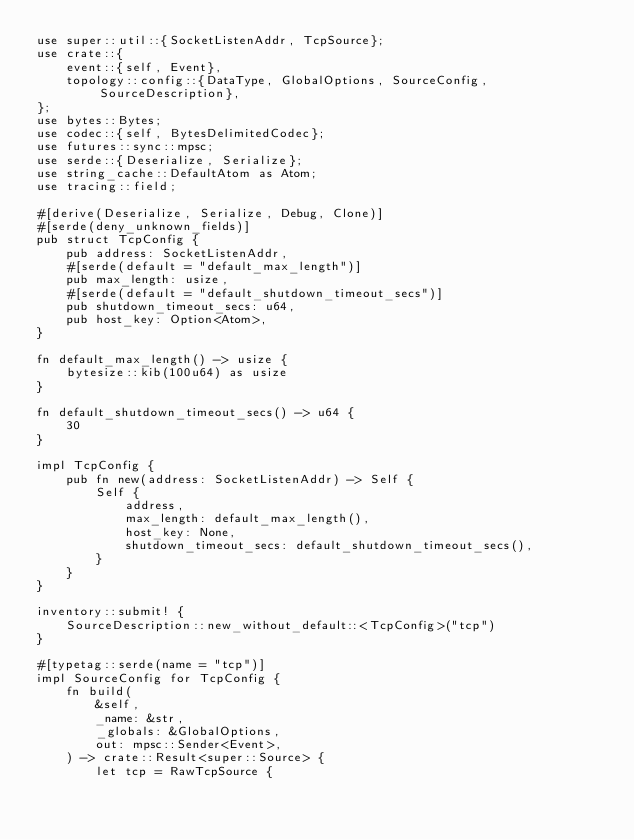Convert code to text. <code><loc_0><loc_0><loc_500><loc_500><_Rust_>use super::util::{SocketListenAddr, TcpSource};
use crate::{
    event::{self, Event},
    topology::config::{DataType, GlobalOptions, SourceConfig, SourceDescription},
};
use bytes::Bytes;
use codec::{self, BytesDelimitedCodec};
use futures::sync::mpsc;
use serde::{Deserialize, Serialize};
use string_cache::DefaultAtom as Atom;
use tracing::field;

#[derive(Deserialize, Serialize, Debug, Clone)]
#[serde(deny_unknown_fields)]
pub struct TcpConfig {
    pub address: SocketListenAddr,
    #[serde(default = "default_max_length")]
    pub max_length: usize,
    #[serde(default = "default_shutdown_timeout_secs")]
    pub shutdown_timeout_secs: u64,
    pub host_key: Option<Atom>,
}

fn default_max_length() -> usize {
    bytesize::kib(100u64) as usize
}

fn default_shutdown_timeout_secs() -> u64 {
    30
}

impl TcpConfig {
    pub fn new(address: SocketListenAddr) -> Self {
        Self {
            address,
            max_length: default_max_length(),
            host_key: None,
            shutdown_timeout_secs: default_shutdown_timeout_secs(),
        }
    }
}

inventory::submit! {
    SourceDescription::new_without_default::<TcpConfig>("tcp")
}

#[typetag::serde(name = "tcp")]
impl SourceConfig for TcpConfig {
    fn build(
        &self,
        _name: &str,
        _globals: &GlobalOptions,
        out: mpsc::Sender<Event>,
    ) -> crate::Result<super::Source> {
        let tcp = RawTcpSource {</code> 